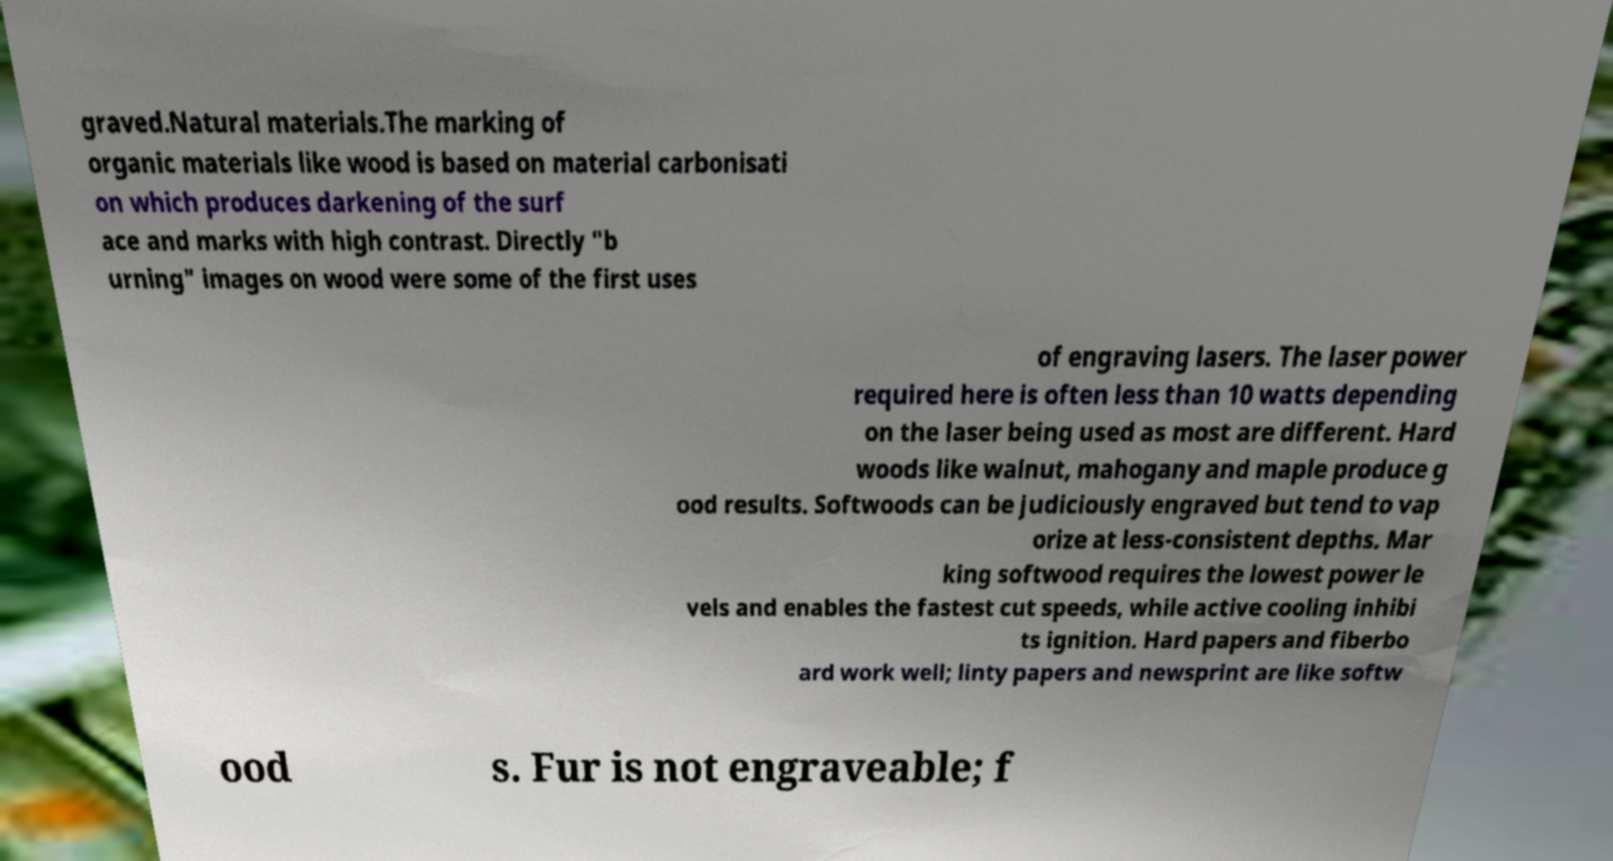Please read and relay the text visible in this image. What does it say? graved.Natural materials.The marking of organic materials like wood is based on material carbonisati on which produces darkening of the surf ace and marks with high contrast. Directly "b urning" images on wood were some of the first uses of engraving lasers. The laser power required here is often less than 10 watts depending on the laser being used as most are different. Hard woods like walnut, mahogany and maple produce g ood results. Softwoods can be judiciously engraved but tend to vap orize at less-consistent depths. Mar king softwood requires the lowest power le vels and enables the fastest cut speeds, while active cooling inhibi ts ignition. Hard papers and fiberbo ard work well; linty papers and newsprint are like softw ood s. Fur is not engraveable; f 